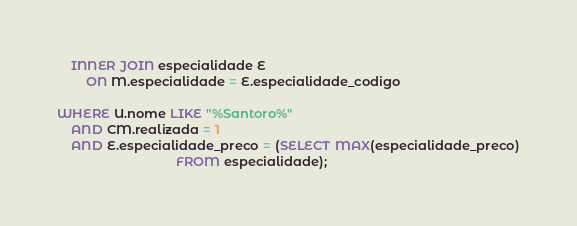Convert code to text. <code><loc_0><loc_0><loc_500><loc_500><_SQL_>    INNER JOIN especialidade E
        ON M.especialidade = E.especialidade_codigo

WHERE U.nome LIKE "%Santoro%"
    AND CM.realizada = 1
    AND E.especialidade_preco = (SELECT MAX(especialidade_preco)
                                 FROM especialidade);
</code> 